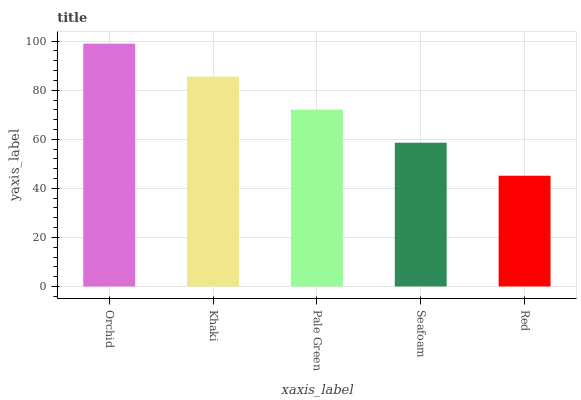Is Red the minimum?
Answer yes or no. Yes. Is Orchid the maximum?
Answer yes or no. Yes. Is Khaki the minimum?
Answer yes or no. No. Is Khaki the maximum?
Answer yes or no. No. Is Orchid greater than Khaki?
Answer yes or no. Yes. Is Khaki less than Orchid?
Answer yes or no. Yes. Is Khaki greater than Orchid?
Answer yes or no. No. Is Orchid less than Khaki?
Answer yes or no. No. Is Pale Green the high median?
Answer yes or no. Yes. Is Pale Green the low median?
Answer yes or no. Yes. Is Orchid the high median?
Answer yes or no. No. Is Orchid the low median?
Answer yes or no. No. 